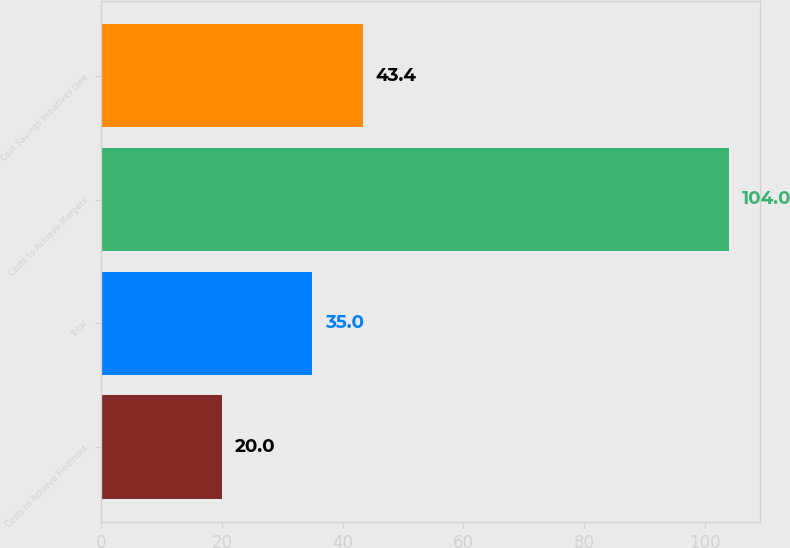Convert chart to OTSL. <chart><loc_0><loc_0><loc_500><loc_500><bar_chart><fcel>Costs to Achieve Piedmont<fcel>Total<fcel>Costs to Achieve Mergers<fcel>Cost Savings Initiatives (see<nl><fcel>20<fcel>35<fcel>104<fcel>43.4<nl></chart> 